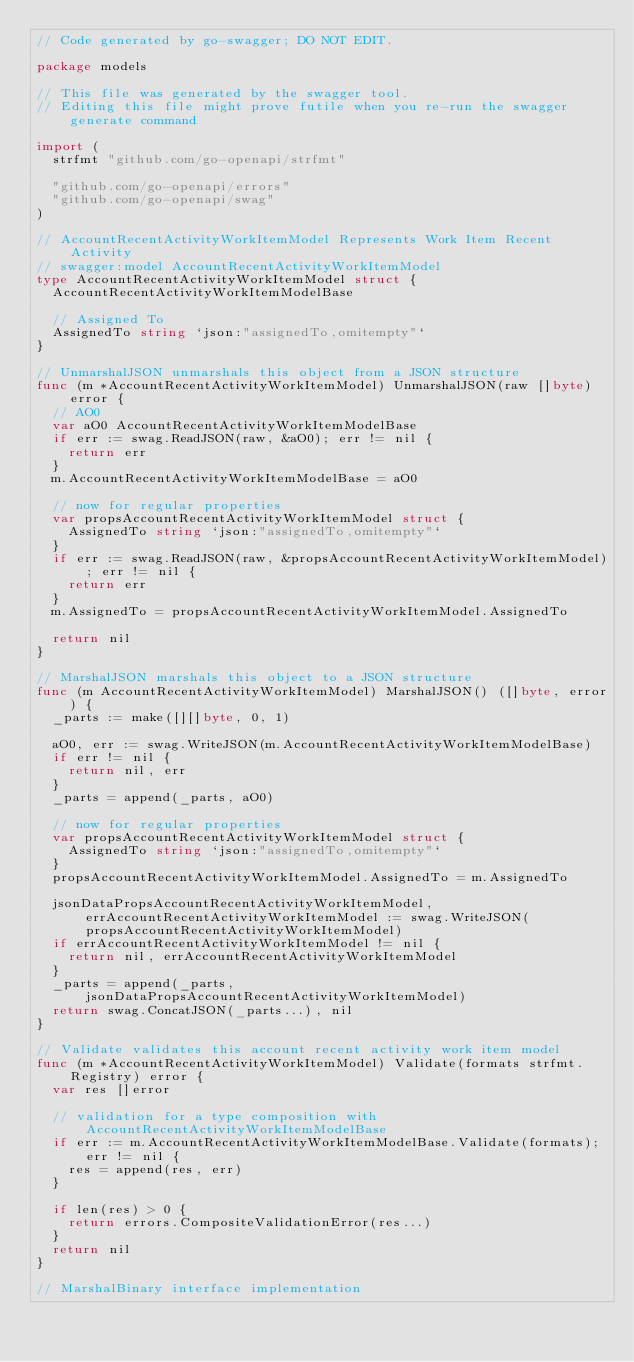<code> <loc_0><loc_0><loc_500><loc_500><_Go_>// Code generated by go-swagger; DO NOT EDIT.

package models

// This file was generated by the swagger tool.
// Editing this file might prove futile when you re-run the swagger generate command

import (
	strfmt "github.com/go-openapi/strfmt"

	"github.com/go-openapi/errors"
	"github.com/go-openapi/swag"
)

// AccountRecentActivityWorkItemModel Represents Work Item Recent Activity
// swagger:model AccountRecentActivityWorkItemModel
type AccountRecentActivityWorkItemModel struct {
	AccountRecentActivityWorkItemModelBase

	// Assigned To
	AssignedTo string `json:"assignedTo,omitempty"`
}

// UnmarshalJSON unmarshals this object from a JSON structure
func (m *AccountRecentActivityWorkItemModel) UnmarshalJSON(raw []byte) error {
	// AO0
	var aO0 AccountRecentActivityWorkItemModelBase
	if err := swag.ReadJSON(raw, &aO0); err != nil {
		return err
	}
	m.AccountRecentActivityWorkItemModelBase = aO0

	// now for regular properties
	var propsAccountRecentActivityWorkItemModel struct {
		AssignedTo string `json:"assignedTo,omitempty"`
	}
	if err := swag.ReadJSON(raw, &propsAccountRecentActivityWorkItemModel); err != nil {
		return err
	}
	m.AssignedTo = propsAccountRecentActivityWorkItemModel.AssignedTo

	return nil
}

// MarshalJSON marshals this object to a JSON structure
func (m AccountRecentActivityWorkItemModel) MarshalJSON() ([]byte, error) {
	_parts := make([][]byte, 0, 1)

	aO0, err := swag.WriteJSON(m.AccountRecentActivityWorkItemModelBase)
	if err != nil {
		return nil, err
	}
	_parts = append(_parts, aO0)

	// now for regular properties
	var propsAccountRecentActivityWorkItemModel struct {
		AssignedTo string `json:"assignedTo,omitempty"`
	}
	propsAccountRecentActivityWorkItemModel.AssignedTo = m.AssignedTo

	jsonDataPropsAccountRecentActivityWorkItemModel, errAccountRecentActivityWorkItemModel := swag.WriteJSON(propsAccountRecentActivityWorkItemModel)
	if errAccountRecentActivityWorkItemModel != nil {
		return nil, errAccountRecentActivityWorkItemModel
	}
	_parts = append(_parts, jsonDataPropsAccountRecentActivityWorkItemModel)
	return swag.ConcatJSON(_parts...), nil
}

// Validate validates this account recent activity work item model
func (m *AccountRecentActivityWorkItemModel) Validate(formats strfmt.Registry) error {
	var res []error

	// validation for a type composition with AccountRecentActivityWorkItemModelBase
	if err := m.AccountRecentActivityWorkItemModelBase.Validate(formats); err != nil {
		res = append(res, err)
	}

	if len(res) > 0 {
		return errors.CompositeValidationError(res...)
	}
	return nil
}

// MarshalBinary interface implementation</code> 